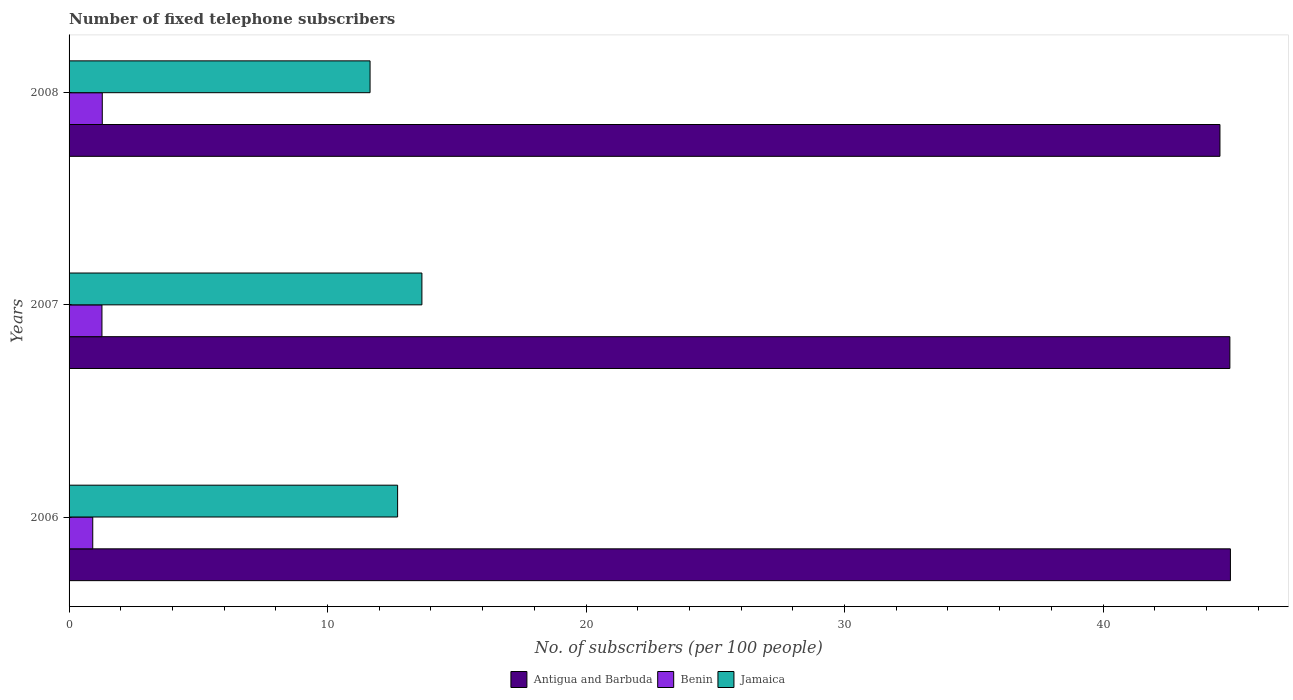Are the number of bars per tick equal to the number of legend labels?
Provide a short and direct response. Yes. Are the number of bars on each tick of the Y-axis equal?
Provide a succinct answer. Yes. In how many cases, is the number of bars for a given year not equal to the number of legend labels?
Your response must be concise. 0. What is the number of fixed telephone subscribers in Antigua and Barbuda in 2008?
Your answer should be compact. 44.52. Across all years, what is the maximum number of fixed telephone subscribers in Jamaica?
Your answer should be very brief. 13.65. Across all years, what is the minimum number of fixed telephone subscribers in Antigua and Barbuda?
Give a very brief answer. 44.52. What is the total number of fixed telephone subscribers in Benin in the graph?
Provide a succinct answer. 3.47. What is the difference between the number of fixed telephone subscribers in Jamaica in 2007 and that in 2008?
Provide a succinct answer. 2.01. What is the difference between the number of fixed telephone subscribers in Benin in 2006 and the number of fixed telephone subscribers in Jamaica in 2008?
Ensure brevity in your answer.  -10.73. What is the average number of fixed telephone subscribers in Jamaica per year?
Your answer should be compact. 12.67. In the year 2006, what is the difference between the number of fixed telephone subscribers in Jamaica and number of fixed telephone subscribers in Antigua and Barbuda?
Offer a terse response. -32.22. In how many years, is the number of fixed telephone subscribers in Antigua and Barbuda greater than 32 ?
Keep it short and to the point. 3. What is the ratio of the number of fixed telephone subscribers in Antigua and Barbuda in 2007 to that in 2008?
Provide a succinct answer. 1.01. What is the difference between the highest and the second highest number of fixed telephone subscribers in Antigua and Barbuda?
Make the answer very short. 0.02. What is the difference between the highest and the lowest number of fixed telephone subscribers in Antigua and Barbuda?
Your response must be concise. 0.4. Is the sum of the number of fixed telephone subscribers in Antigua and Barbuda in 2007 and 2008 greater than the maximum number of fixed telephone subscribers in Benin across all years?
Provide a short and direct response. Yes. What does the 3rd bar from the top in 2008 represents?
Your answer should be very brief. Antigua and Barbuda. What does the 1st bar from the bottom in 2008 represents?
Give a very brief answer. Antigua and Barbuda. Are all the bars in the graph horizontal?
Provide a short and direct response. Yes. What is the difference between two consecutive major ticks on the X-axis?
Your answer should be compact. 10. Are the values on the major ticks of X-axis written in scientific E-notation?
Offer a terse response. No. How many legend labels are there?
Provide a short and direct response. 3. How are the legend labels stacked?
Make the answer very short. Horizontal. What is the title of the graph?
Your response must be concise. Number of fixed telephone subscribers. What is the label or title of the X-axis?
Provide a succinct answer. No. of subscribers (per 100 people). What is the label or title of the Y-axis?
Make the answer very short. Years. What is the No. of subscribers (per 100 people) of Antigua and Barbuda in 2006?
Offer a very short reply. 44.93. What is the No. of subscribers (per 100 people) in Benin in 2006?
Your answer should be very brief. 0.92. What is the No. of subscribers (per 100 people) of Jamaica in 2006?
Offer a very short reply. 12.71. What is the No. of subscribers (per 100 people) of Antigua and Barbuda in 2007?
Offer a very short reply. 44.91. What is the No. of subscribers (per 100 people) of Benin in 2007?
Offer a very short reply. 1.27. What is the No. of subscribers (per 100 people) of Jamaica in 2007?
Your answer should be compact. 13.65. What is the No. of subscribers (per 100 people) in Antigua and Barbuda in 2008?
Keep it short and to the point. 44.52. What is the No. of subscribers (per 100 people) of Benin in 2008?
Make the answer very short. 1.28. What is the No. of subscribers (per 100 people) in Jamaica in 2008?
Offer a very short reply. 11.64. Across all years, what is the maximum No. of subscribers (per 100 people) in Antigua and Barbuda?
Offer a terse response. 44.93. Across all years, what is the maximum No. of subscribers (per 100 people) in Benin?
Your answer should be very brief. 1.28. Across all years, what is the maximum No. of subscribers (per 100 people) of Jamaica?
Offer a very short reply. 13.65. Across all years, what is the minimum No. of subscribers (per 100 people) in Antigua and Barbuda?
Give a very brief answer. 44.52. Across all years, what is the minimum No. of subscribers (per 100 people) of Benin?
Provide a succinct answer. 0.92. Across all years, what is the minimum No. of subscribers (per 100 people) in Jamaica?
Ensure brevity in your answer.  11.64. What is the total No. of subscribers (per 100 people) in Antigua and Barbuda in the graph?
Your answer should be very brief. 134.36. What is the total No. of subscribers (per 100 people) in Benin in the graph?
Provide a succinct answer. 3.47. What is the total No. of subscribers (per 100 people) of Jamaica in the graph?
Your answer should be very brief. 38. What is the difference between the No. of subscribers (per 100 people) of Antigua and Barbuda in 2006 and that in 2007?
Provide a succinct answer. 0.02. What is the difference between the No. of subscribers (per 100 people) of Benin in 2006 and that in 2007?
Give a very brief answer. -0.36. What is the difference between the No. of subscribers (per 100 people) of Jamaica in 2006 and that in 2007?
Offer a terse response. -0.94. What is the difference between the No. of subscribers (per 100 people) of Antigua and Barbuda in 2006 and that in 2008?
Your answer should be very brief. 0.4. What is the difference between the No. of subscribers (per 100 people) of Benin in 2006 and that in 2008?
Provide a succinct answer. -0.37. What is the difference between the No. of subscribers (per 100 people) in Jamaica in 2006 and that in 2008?
Provide a succinct answer. 1.07. What is the difference between the No. of subscribers (per 100 people) of Antigua and Barbuda in 2007 and that in 2008?
Ensure brevity in your answer.  0.38. What is the difference between the No. of subscribers (per 100 people) of Benin in 2007 and that in 2008?
Make the answer very short. -0.01. What is the difference between the No. of subscribers (per 100 people) in Jamaica in 2007 and that in 2008?
Your response must be concise. 2.01. What is the difference between the No. of subscribers (per 100 people) of Antigua and Barbuda in 2006 and the No. of subscribers (per 100 people) of Benin in 2007?
Offer a terse response. 43.66. What is the difference between the No. of subscribers (per 100 people) of Antigua and Barbuda in 2006 and the No. of subscribers (per 100 people) of Jamaica in 2007?
Provide a succinct answer. 31.28. What is the difference between the No. of subscribers (per 100 people) of Benin in 2006 and the No. of subscribers (per 100 people) of Jamaica in 2007?
Offer a very short reply. -12.73. What is the difference between the No. of subscribers (per 100 people) in Antigua and Barbuda in 2006 and the No. of subscribers (per 100 people) in Benin in 2008?
Offer a terse response. 43.64. What is the difference between the No. of subscribers (per 100 people) in Antigua and Barbuda in 2006 and the No. of subscribers (per 100 people) in Jamaica in 2008?
Your answer should be compact. 33.28. What is the difference between the No. of subscribers (per 100 people) of Benin in 2006 and the No. of subscribers (per 100 people) of Jamaica in 2008?
Your answer should be compact. -10.73. What is the difference between the No. of subscribers (per 100 people) in Antigua and Barbuda in 2007 and the No. of subscribers (per 100 people) in Benin in 2008?
Offer a terse response. 43.62. What is the difference between the No. of subscribers (per 100 people) of Antigua and Barbuda in 2007 and the No. of subscribers (per 100 people) of Jamaica in 2008?
Make the answer very short. 33.26. What is the difference between the No. of subscribers (per 100 people) in Benin in 2007 and the No. of subscribers (per 100 people) in Jamaica in 2008?
Give a very brief answer. -10.37. What is the average No. of subscribers (per 100 people) of Antigua and Barbuda per year?
Your response must be concise. 44.79. What is the average No. of subscribers (per 100 people) in Benin per year?
Offer a terse response. 1.16. What is the average No. of subscribers (per 100 people) in Jamaica per year?
Make the answer very short. 12.67. In the year 2006, what is the difference between the No. of subscribers (per 100 people) of Antigua and Barbuda and No. of subscribers (per 100 people) of Benin?
Ensure brevity in your answer.  44.01. In the year 2006, what is the difference between the No. of subscribers (per 100 people) in Antigua and Barbuda and No. of subscribers (per 100 people) in Jamaica?
Keep it short and to the point. 32.22. In the year 2006, what is the difference between the No. of subscribers (per 100 people) in Benin and No. of subscribers (per 100 people) in Jamaica?
Provide a short and direct response. -11.79. In the year 2007, what is the difference between the No. of subscribers (per 100 people) of Antigua and Barbuda and No. of subscribers (per 100 people) of Benin?
Your response must be concise. 43.63. In the year 2007, what is the difference between the No. of subscribers (per 100 people) in Antigua and Barbuda and No. of subscribers (per 100 people) in Jamaica?
Provide a succinct answer. 31.26. In the year 2007, what is the difference between the No. of subscribers (per 100 people) of Benin and No. of subscribers (per 100 people) of Jamaica?
Your answer should be compact. -12.38. In the year 2008, what is the difference between the No. of subscribers (per 100 people) in Antigua and Barbuda and No. of subscribers (per 100 people) in Benin?
Make the answer very short. 43.24. In the year 2008, what is the difference between the No. of subscribers (per 100 people) in Antigua and Barbuda and No. of subscribers (per 100 people) in Jamaica?
Your answer should be very brief. 32.88. In the year 2008, what is the difference between the No. of subscribers (per 100 people) of Benin and No. of subscribers (per 100 people) of Jamaica?
Your answer should be compact. -10.36. What is the ratio of the No. of subscribers (per 100 people) in Antigua and Barbuda in 2006 to that in 2007?
Ensure brevity in your answer.  1. What is the ratio of the No. of subscribers (per 100 people) in Benin in 2006 to that in 2007?
Ensure brevity in your answer.  0.72. What is the ratio of the No. of subscribers (per 100 people) in Jamaica in 2006 to that in 2007?
Ensure brevity in your answer.  0.93. What is the ratio of the No. of subscribers (per 100 people) in Antigua and Barbuda in 2006 to that in 2008?
Your answer should be very brief. 1.01. What is the ratio of the No. of subscribers (per 100 people) in Benin in 2006 to that in 2008?
Offer a terse response. 0.71. What is the ratio of the No. of subscribers (per 100 people) of Jamaica in 2006 to that in 2008?
Give a very brief answer. 1.09. What is the ratio of the No. of subscribers (per 100 people) of Antigua and Barbuda in 2007 to that in 2008?
Provide a succinct answer. 1.01. What is the ratio of the No. of subscribers (per 100 people) in Benin in 2007 to that in 2008?
Offer a very short reply. 0.99. What is the ratio of the No. of subscribers (per 100 people) of Jamaica in 2007 to that in 2008?
Your answer should be very brief. 1.17. What is the difference between the highest and the second highest No. of subscribers (per 100 people) of Antigua and Barbuda?
Give a very brief answer. 0.02. What is the difference between the highest and the second highest No. of subscribers (per 100 people) in Benin?
Give a very brief answer. 0.01. What is the difference between the highest and the second highest No. of subscribers (per 100 people) in Jamaica?
Your answer should be compact. 0.94. What is the difference between the highest and the lowest No. of subscribers (per 100 people) in Antigua and Barbuda?
Make the answer very short. 0.4. What is the difference between the highest and the lowest No. of subscribers (per 100 people) in Benin?
Your response must be concise. 0.37. What is the difference between the highest and the lowest No. of subscribers (per 100 people) of Jamaica?
Give a very brief answer. 2.01. 